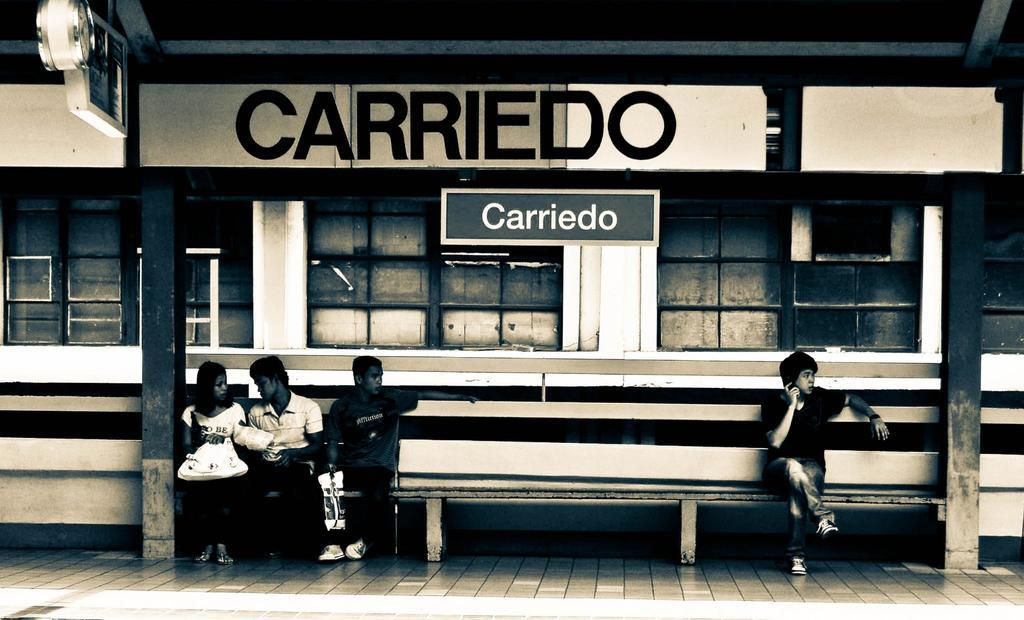How many persons are in the image? There are persons in the image. What are the persons wearing? The persons are wearing clothes. What are the persons doing in the image? The persons are sitting on a bench. Where is the bench located in relation to the building? The bench is in front of a building. What can be seen on the sides of the image? There are poles on both the left and right sides of the image. What type of tree can be seen growing on the bench in the image? There is no tree growing on the bench in the image. Can you tell me how many experts are present in the image? There is no mention of experts in the image; it features persons sitting on a bench. 